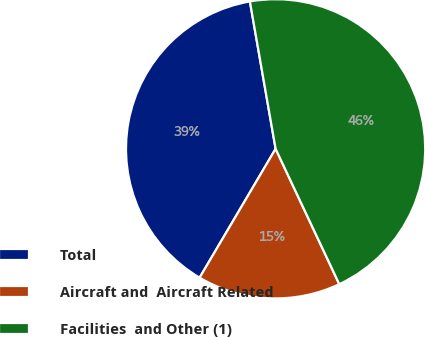<chart> <loc_0><loc_0><loc_500><loc_500><pie_chart><fcel>Total<fcel>Aircraft and  Aircraft Related<fcel>Facilities  and Other (1)<nl><fcel>38.77%<fcel>15.48%<fcel>45.75%<nl></chart> 